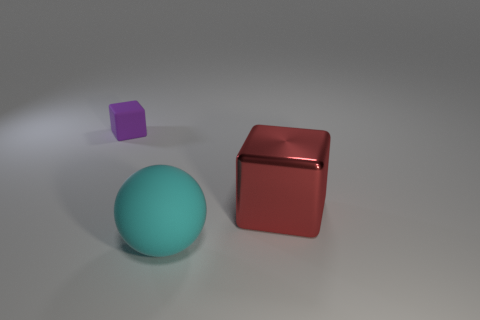Can you describe the textures of the objects? Certainly! The cyan ball has a matte texture, diffusing the light softly. The shiny red cube, on the other hand, reflects light strongly, indicating a smooth, polished surface. Lastly, the small purple cube has a slight glossiness that is less reflective than the red cube but shinier than the cyan ball. 